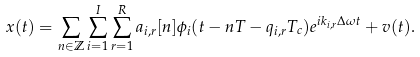<formula> <loc_0><loc_0><loc_500><loc_500>x ( t ) = \sum _ { n \in \mathbb { Z } } \sum _ { i = 1 } ^ { I } \sum _ { r = 1 } ^ { R } a _ { i , r } [ n ] \phi _ { i } ( t - n T - q _ { i , r } T _ { c } ) e ^ { i k _ { i , r } \Delta \omega t } + v ( t ) .</formula> 